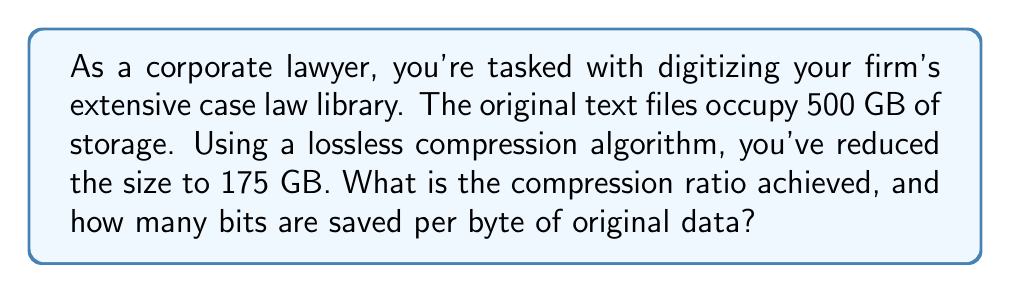Give your solution to this math problem. To solve this problem, we need to follow these steps:

1. Calculate the compression ratio:
   The compression ratio is defined as the ratio of the uncompressed size to the compressed size.
   
   $$\text{Compression Ratio} = \frac{\text{Uncompressed Size}}{\text{Compressed Size}}$$
   
   $$\text{Compression Ratio} = \frac{500 \text{ GB}}{175 \text{ GB}} = \frac{500}{175} = 2.857$$

2. Calculate the number of bits saved per byte:
   First, we need to calculate the total number of bytes saved:
   
   $$\text{Bytes Saved} = 500 \text{ GB} - 175 \text{ GB} = 325 \text{ GB}$$
   
   Now, we convert this to bits:
   
   $$\text{Bits Saved} = 325 \text{ GB} \times 8 \text{ bits/byte} \times 1024^3 \text{ bytes/GB}$$
   
   To find bits saved per original byte:
   
   $$\text{Bits Saved per Byte} = \frac{\text{Bits Saved}}{\text{Original Bytes}}$$
   
   $$= \frac{325 \times 8 \times 1024^3}{500 \times 1024^3} = \frac{325 \times 8}{500} = 5.2 \text{ bits}$$

This means that for every byte in the original data, 5.2 bits are saved through compression.
Answer: The compression ratio achieved is 2.857:1, and 5.2 bits are saved per byte of original data. 